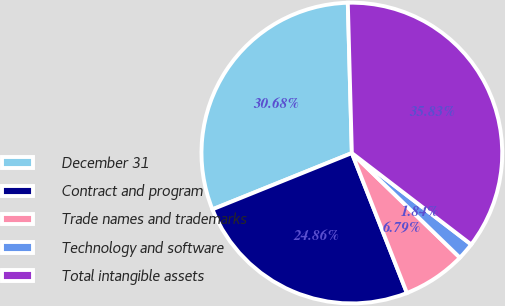Convert chart to OTSL. <chart><loc_0><loc_0><loc_500><loc_500><pie_chart><fcel>December 31<fcel>Contract and program<fcel>Trade names and trademarks<fcel>Technology and software<fcel>Total intangible assets<nl><fcel>30.68%<fcel>24.86%<fcel>6.79%<fcel>1.84%<fcel>35.83%<nl></chart> 